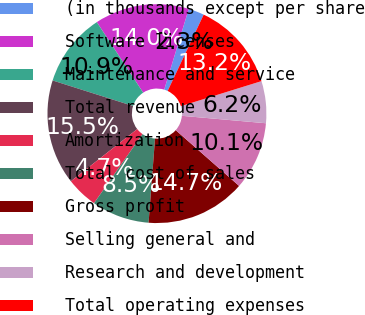Convert chart. <chart><loc_0><loc_0><loc_500><loc_500><pie_chart><fcel>(in thousands except per share<fcel>Software licenses<fcel>Maintenance and service<fcel>Total revenue<fcel>Amortization<fcel>Total cost of sales<fcel>Gross profit<fcel>Selling general and<fcel>Research and development<fcel>Total operating expenses<nl><fcel>2.33%<fcel>13.95%<fcel>10.85%<fcel>15.5%<fcel>4.65%<fcel>8.53%<fcel>14.73%<fcel>10.08%<fcel>6.2%<fcel>13.18%<nl></chart> 